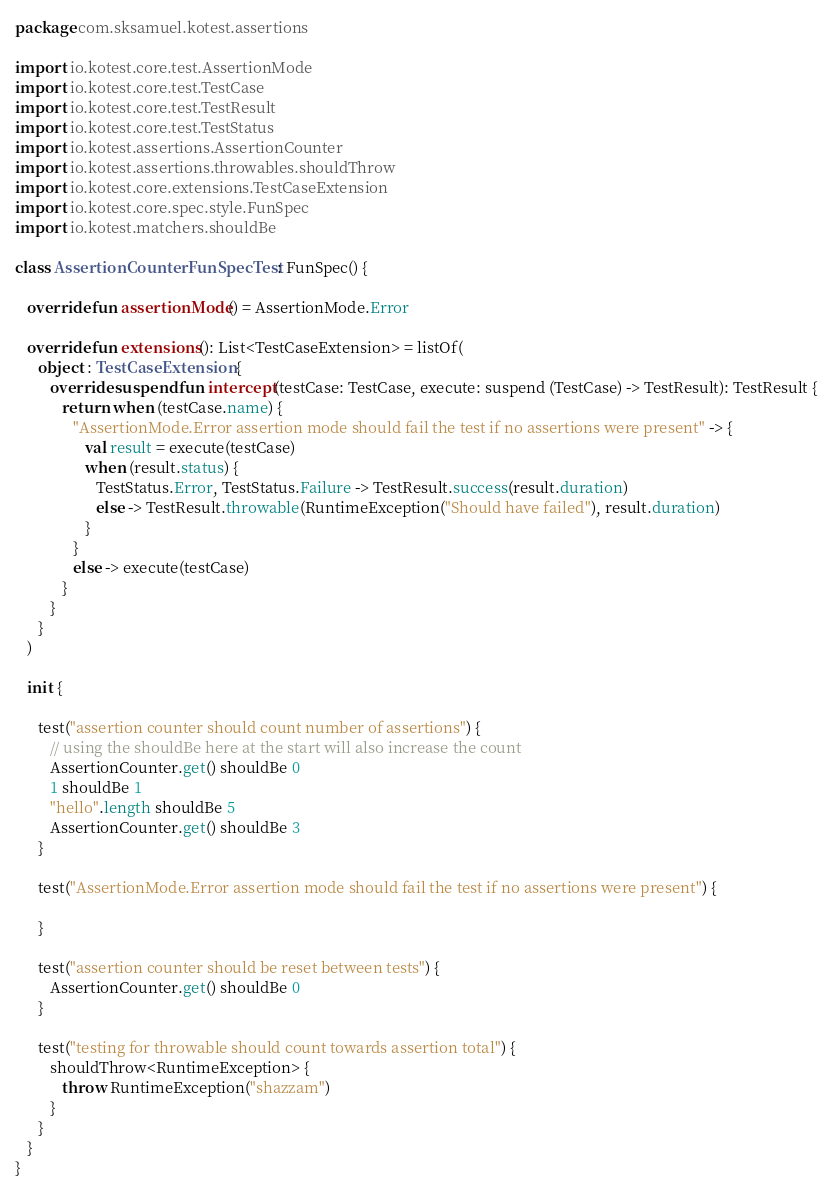Convert code to text. <code><loc_0><loc_0><loc_500><loc_500><_Kotlin_>package com.sksamuel.kotest.assertions

import io.kotest.core.test.AssertionMode
import io.kotest.core.test.TestCase
import io.kotest.core.test.TestResult
import io.kotest.core.test.TestStatus
import io.kotest.assertions.AssertionCounter
import io.kotest.assertions.throwables.shouldThrow
import io.kotest.core.extensions.TestCaseExtension
import io.kotest.core.spec.style.FunSpec
import io.kotest.matchers.shouldBe

class AssertionCounterFunSpecTest : FunSpec() {

   override fun assertionMode() = AssertionMode.Error

   override fun extensions(): List<TestCaseExtension> = listOf(
      object : TestCaseExtension {
         override suspend fun intercept(testCase: TestCase, execute: suspend (TestCase) -> TestResult): TestResult {
            return when (testCase.name) {
               "AssertionMode.Error assertion mode should fail the test if no assertions were present" -> {
                  val result = execute(testCase)
                  when (result.status) {
                     TestStatus.Error, TestStatus.Failure -> TestResult.success(result.duration)
                     else -> TestResult.throwable(RuntimeException("Should have failed"), result.duration)
                  }
               }
               else -> execute(testCase)
            }
         }
      }
   )

   init {

      test("assertion counter should count number of assertions") {
         // using the shouldBe here at the start will also increase the count
         AssertionCounter.get() shouldBe 0
         1 shouldBe 1
         "hello".length shouldBe 5
         AssertionCounter.get() shouldBe 3
      }

      test("AssertionMode.Error assertion mode should fail the test if no assertions were present") {

      }

      test("assertion counter should be reset between tests") {
         AssertionCounter.get() shouldBe 0
      }

      test("testing for throwable should count towards assertion total") {
         shouldThrow<RuntimeException> {
            throw RuntimeException("shazzam")
         }
      }
   }
}
</code> 